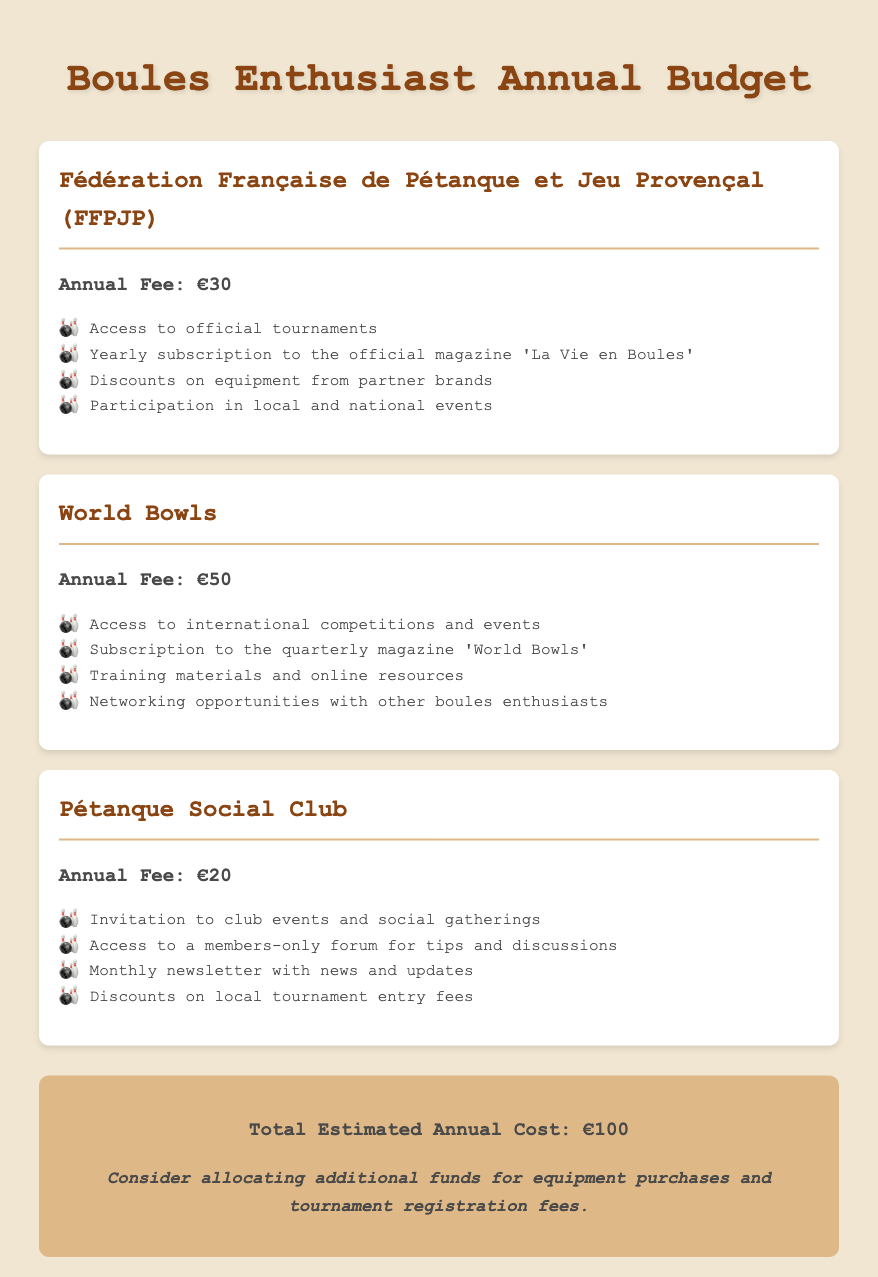What is the annual fee for FFPJP? The annual fee for FFPJP is explicitly listed in the document as €30.
Answer: €30 What magazine is included with the FFPJP membership? The document states that the membership includes a yearly subscription to the magazine 'La Vie en Boules'.
Answer: 'La Vie en Boules' How much does a membership for the Pétanque Social Club cost? The membership fee for the Pétanque Social Club is mentioned as €20 in the budget.
Answer: €20 What total amount does the budget estimate for yearly subscriptions? The total cost is calculated and presented at the end of the document as €100.
Answer: €100 Which organization provides access to international competitions? The document clearly states that World Bowls provides access to international competitions and events.
Answer: World Bowls What is one benefit of joining the Pétanque Social Club? The document lists several benefits; one notable benefit is an invitation to club events and social gatherings.
Answer: Club events and social gatherings What type of events does FFPJP allow participation in? FFPJP membership allows for participation in local and national events as specified in the document.
Answer: Local and national events How frequently does the World Bowls magazine come out? The document states that the subscription to World Bowls is quarterly, indicating it comes out four times a year.
Answer: Quarterly What is the total annual cost breakdown's additional note? The additional note suggests considering allocating funds for equipment purchases and tournament registration fees.
Answer: Equipment purchases and tournament registration fees 